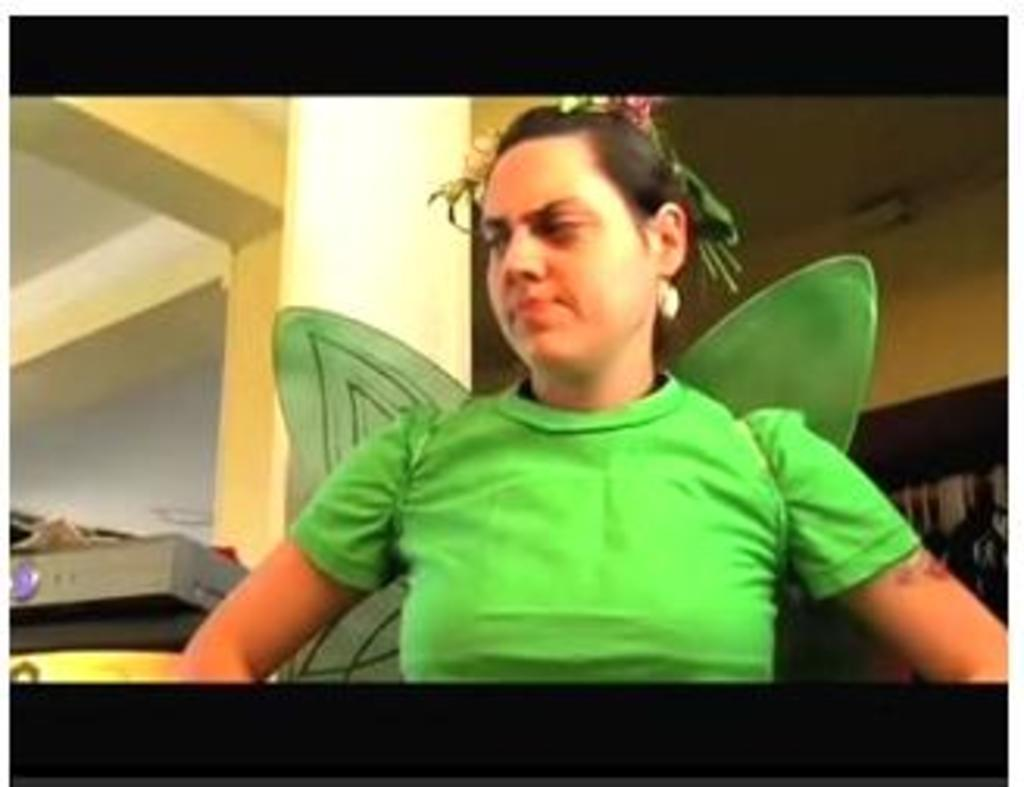Who is the main subject in the center of the picture? There is a woman in the center of the picture. What is the woman wearing? The woman is wearing a green dress. What is the color of the border around the picture? The picture has a black border. What can be seen behind the woman in the image? There is a well visible behind the woman. What is on the right side of the image? There is a curtain on the right side of the image. What type of pest can be seen crawling on the woman's dress in the image? There are no pests visible on the woman's dress in the image. Are there any dinosaurs present in the image? No, there are no dinosaurs present in the image. What is the woman holding over her head to protect herself from the rain in the image? There is no umbrella or indication of rain in the image. 